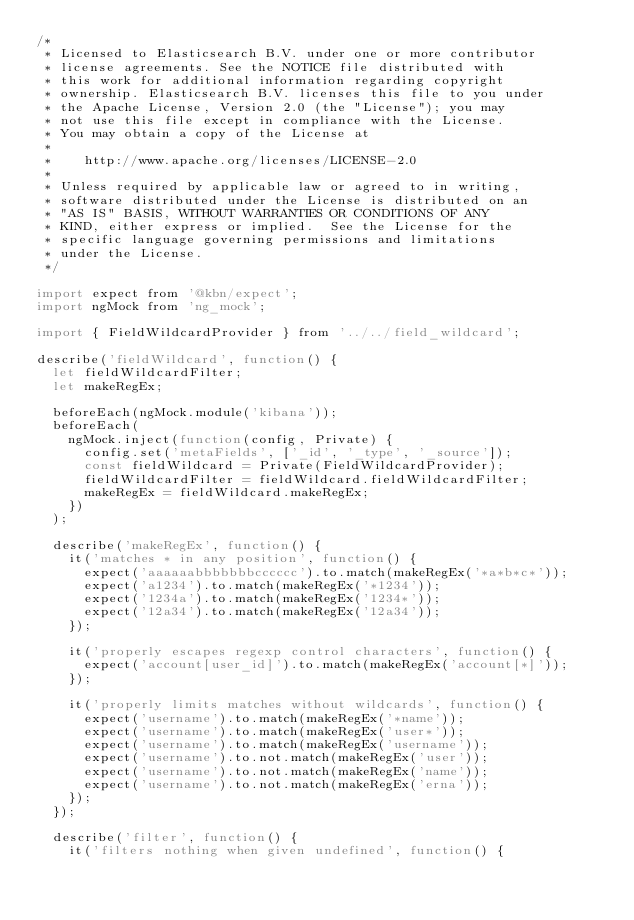Convert code to text. <code><loc_0><loc_0><loc_500><loc_500><_JavaScript_>/*
 * Licensed to Elasticsearch B.V. under one or more contributor
 * license agreements. See the NOTICE file distributed with
 * this work for additional information regarding copyright
 * ownership. Elasticsearch B.V. licenses this file to you under
 * the Apache License, Version 2.0 (the "License"); you may
 * not use this file except in compliance with the License.
 * You may obtain a copy of the License at
 *
 *    http://www.apache.org/licenses/LICENSE-2.0
 *
 * Unless required by applicable law or agreed to in writing,
 * software distributed under the License is distributed on an
 * "AS IS" BASIS, WITHOUT WARRANTIES OR CONDITIONS OF ANY
 * KIND, either express or implied.  See the License for the
 * specific language governing permissions and limitations
 * under the License.
 */

import expect from '@kbn/expect';
import ngMock from 'ng_mock';

import { FieldWildcardProvider } from '../../field_wildcard';

describe('fieldWildcard', function() {
  let fieldWildcardFilter;
  let makeRegEx;

  beforeEach(ngMock.module('kibana'));
  beforeEach(
    ngMock.inject(function(config, Private) {
      config.set('metaFields', ['_id', '_type', '_source']);
      const fieldWildcard = Private(FieldWildcardProvider);
      fieldWildcardFilter = fieldWildcard.fieldWildcardFilter;
      makeRegEx = fieldWildcard.makeRegEx;
    })
  );

  describe('makeRegEx', function() {
    it('matches * in any position', function() {
      expect('aaaaaabbbbbbbcccccc').to.match(makeRegEx('*a*b*c*'));
      expect('a1234').to.match(makeRegEx('*1234'));
      expect('1234a').to.match(makeRegEx('1234*'));
      expect('12a34').to.match(makeRegEx('12a34'));
    });

    it('properly escapes regexp control characters', function() {
      expect('account[user_id]').to.match(makeRegEx('account[*]'));
    });

    it('properly limits matches without wildcards', function() {
      expect('username').to.match(makeRegEx('*name'));
      expect('username').to.match(makeRegEx('user*'));
      expect('username').to.match(makeRegEx('username'));
      expect('username').to.not.match(makeRegEx('user'));
      expect('username').to.not.match(makeRegEx('name'));
      expect('username').to.not.match(makeRegEx('erna'));
    });
  });

  describe('filter', function() {
    it('filters nothing when given undefined', function() {</code> 